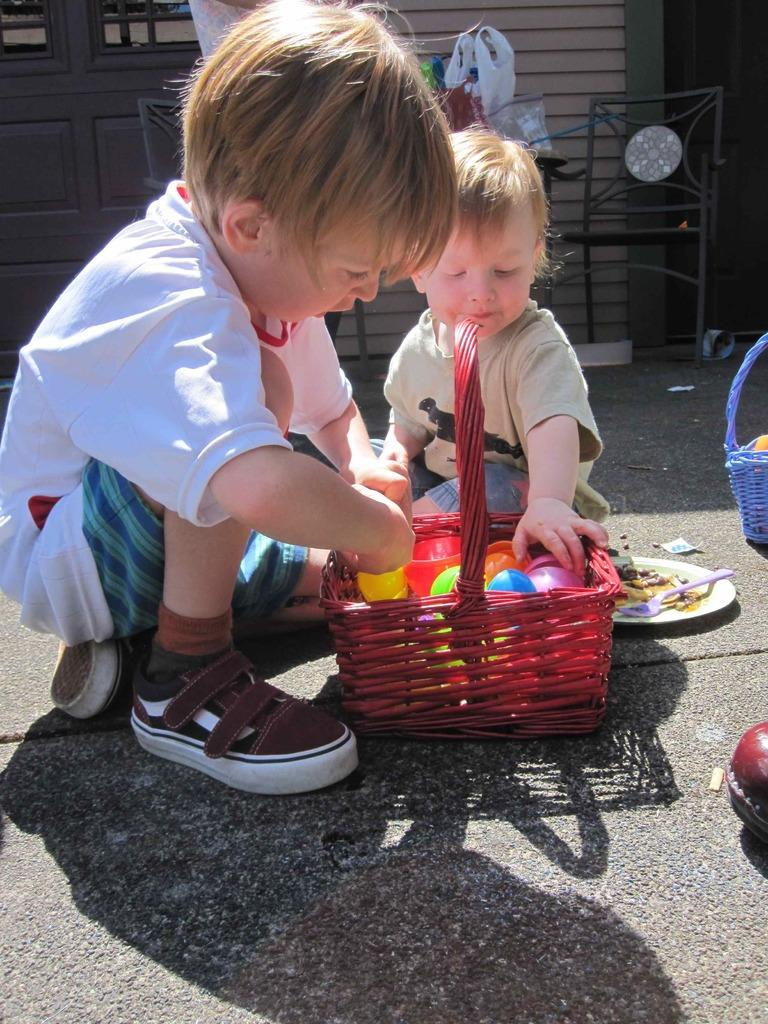How many kids are in the foreground of the picture? There are two kids in the foreground of the picture. What objects are in the foreground of the picture with the kids? There are balls, a plate, baskets, toys, a spoon, and a road in the foreground of the picture. What can be seen in the background of the picture? There are chairs, doors, a wall, a cover, a table, and other objects in the background of the picture. In which direction are the kids heading in the picture? The image does not provide information about the direction the kids are heading; it only shows them in the foreground with various objects. 